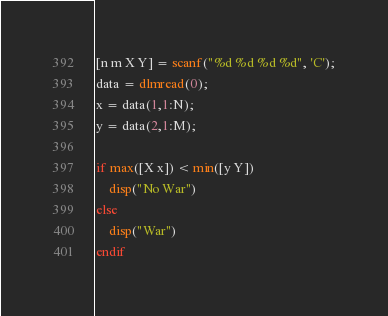<code> <loc_0><loc_0><loc_500><loc_500><_Octave_>[n m X Y] = scanf("%d %d %d %d", 'C');
data = dlmread(0);
x = data(1,1:N);
y = data(2,1:M);

if max([X x]) < min([y Y])
    disp("No War")
else
    disp("War")
endif</code> 